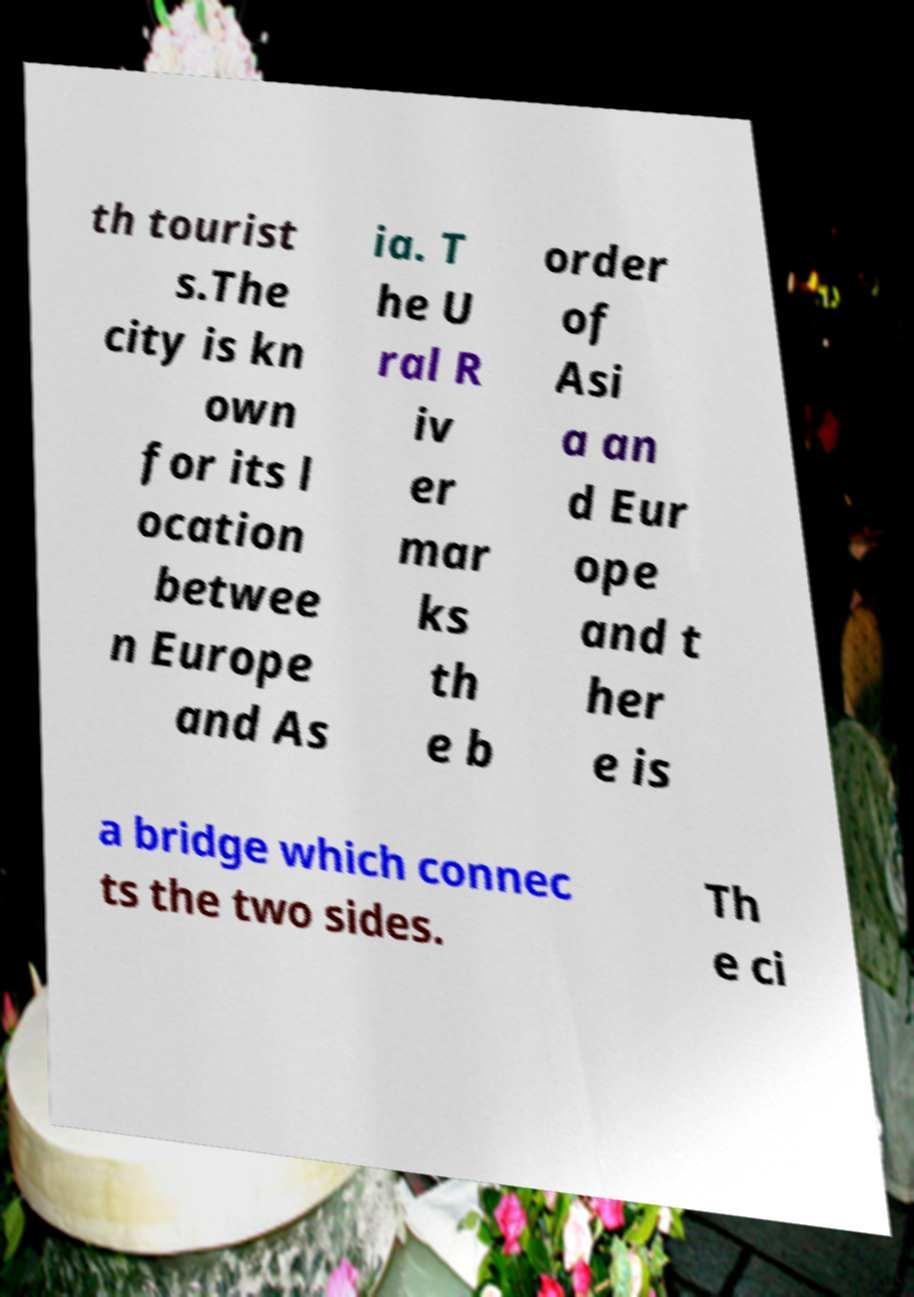Could you assist in decoding the text presented in this image and type it out clearly? th tourist s.The city is kn own for its l ocation betwee n Europe and As ia. T he U ral R iv er mar ks th e b order of Asi a an d Eur ope and t her e is a bridge which connec ts the two sides. Th e ci 